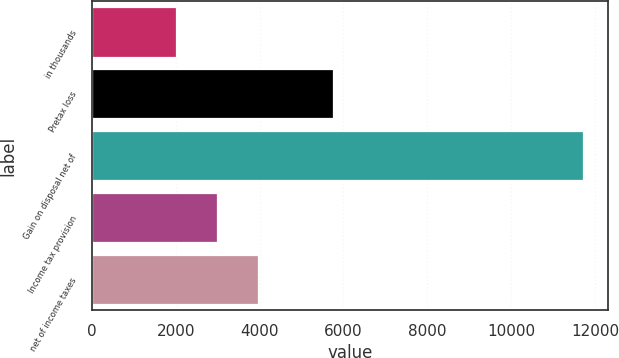Convert chart to OTSL. <chart><loc_0><loc_0><loc_500><loc_500><bar_chart><fcel>in thousands<fcel>Pretax loss<fcel>Gain on disposal net of<fcel>Income tax provision<fcel>net of income taxes<nl><fcel>2013<fcel>5744<fcel>11728<fcel>2984.5<fcel>3956<nl></chart> 